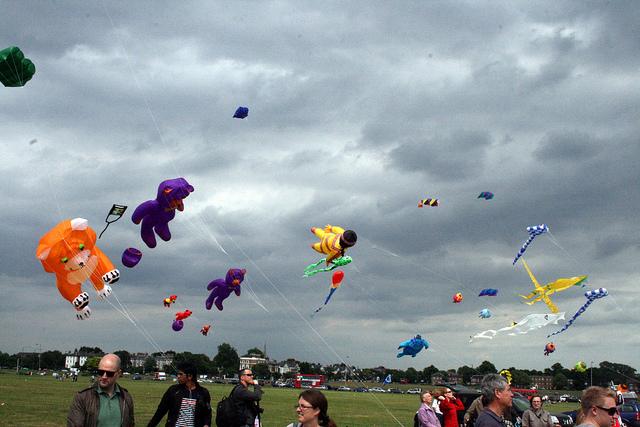Are there clouds in the sky?
Concise answer only. Yes. How many kites are there?
Concise answer only. 15. What are these people doing?
Answer briefly. Flying kites. Is the sky clear?
Answer briefly. No. What is the weather like?
Give a very brief answer. Cloudy. How many kites are there that are not dragons?
Give a very brief answer. 10. 